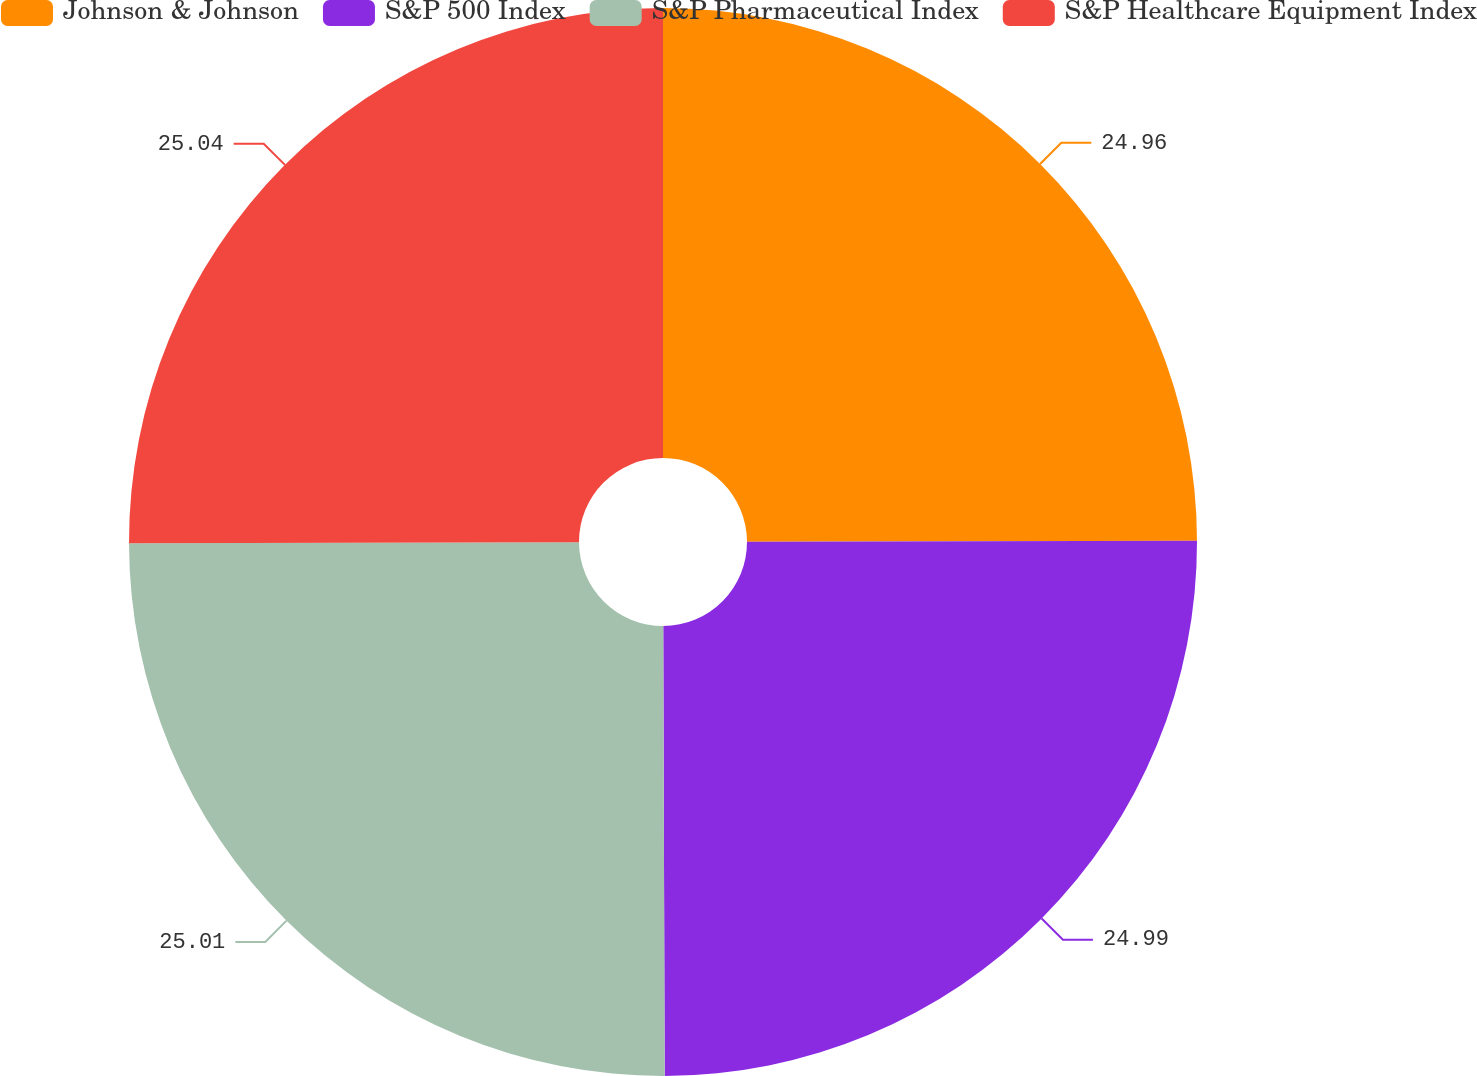Convert chart to OTSL. <chart><loc_0><loc_0><loc_500><loc_500><pie_chart><fcel>Johnson & Johnson<fcel>S&P 500 Index<fcel>S&P Pharmaceutical Index<fcel>S&P Healthcare Equipment Index<nl><fcel>24.96%<fcel>24.99%<fcel>25.01%<fcel>25.04%<nl></chart> 